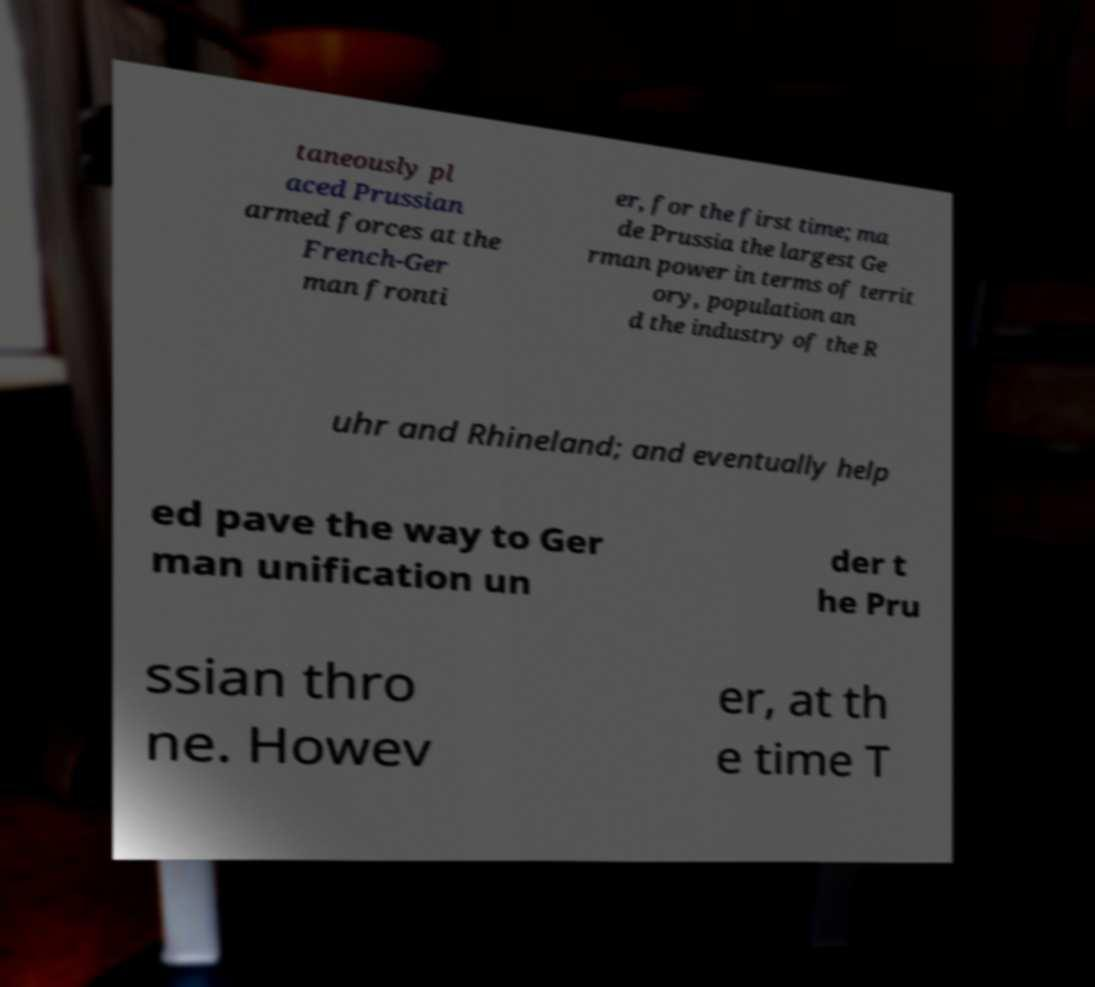Please identify and transcribe the text found in this image. taneously pl aced Prussian armed forces at the French-Ger man fronti er, for the first time; ma de Prussia the largest Ge rman power in terms of territ ory, population an d the industry of the R uhr and Rhineland; and eventually help ed pave the way to Ger man unification un der t he Pru ssian thro ne. Howev er, at th e time T 